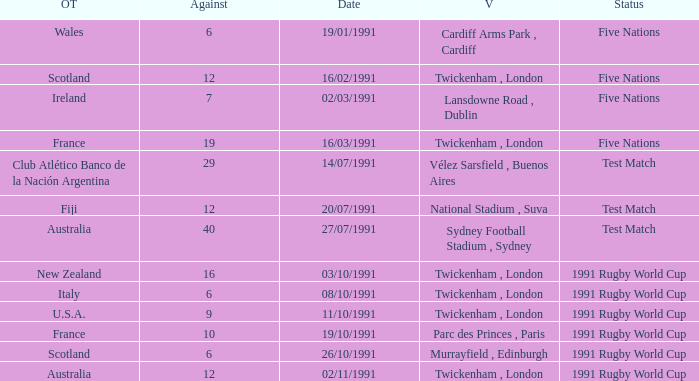What is Opposing Teams, when Date is "11/10/1991"? U.S.A. 